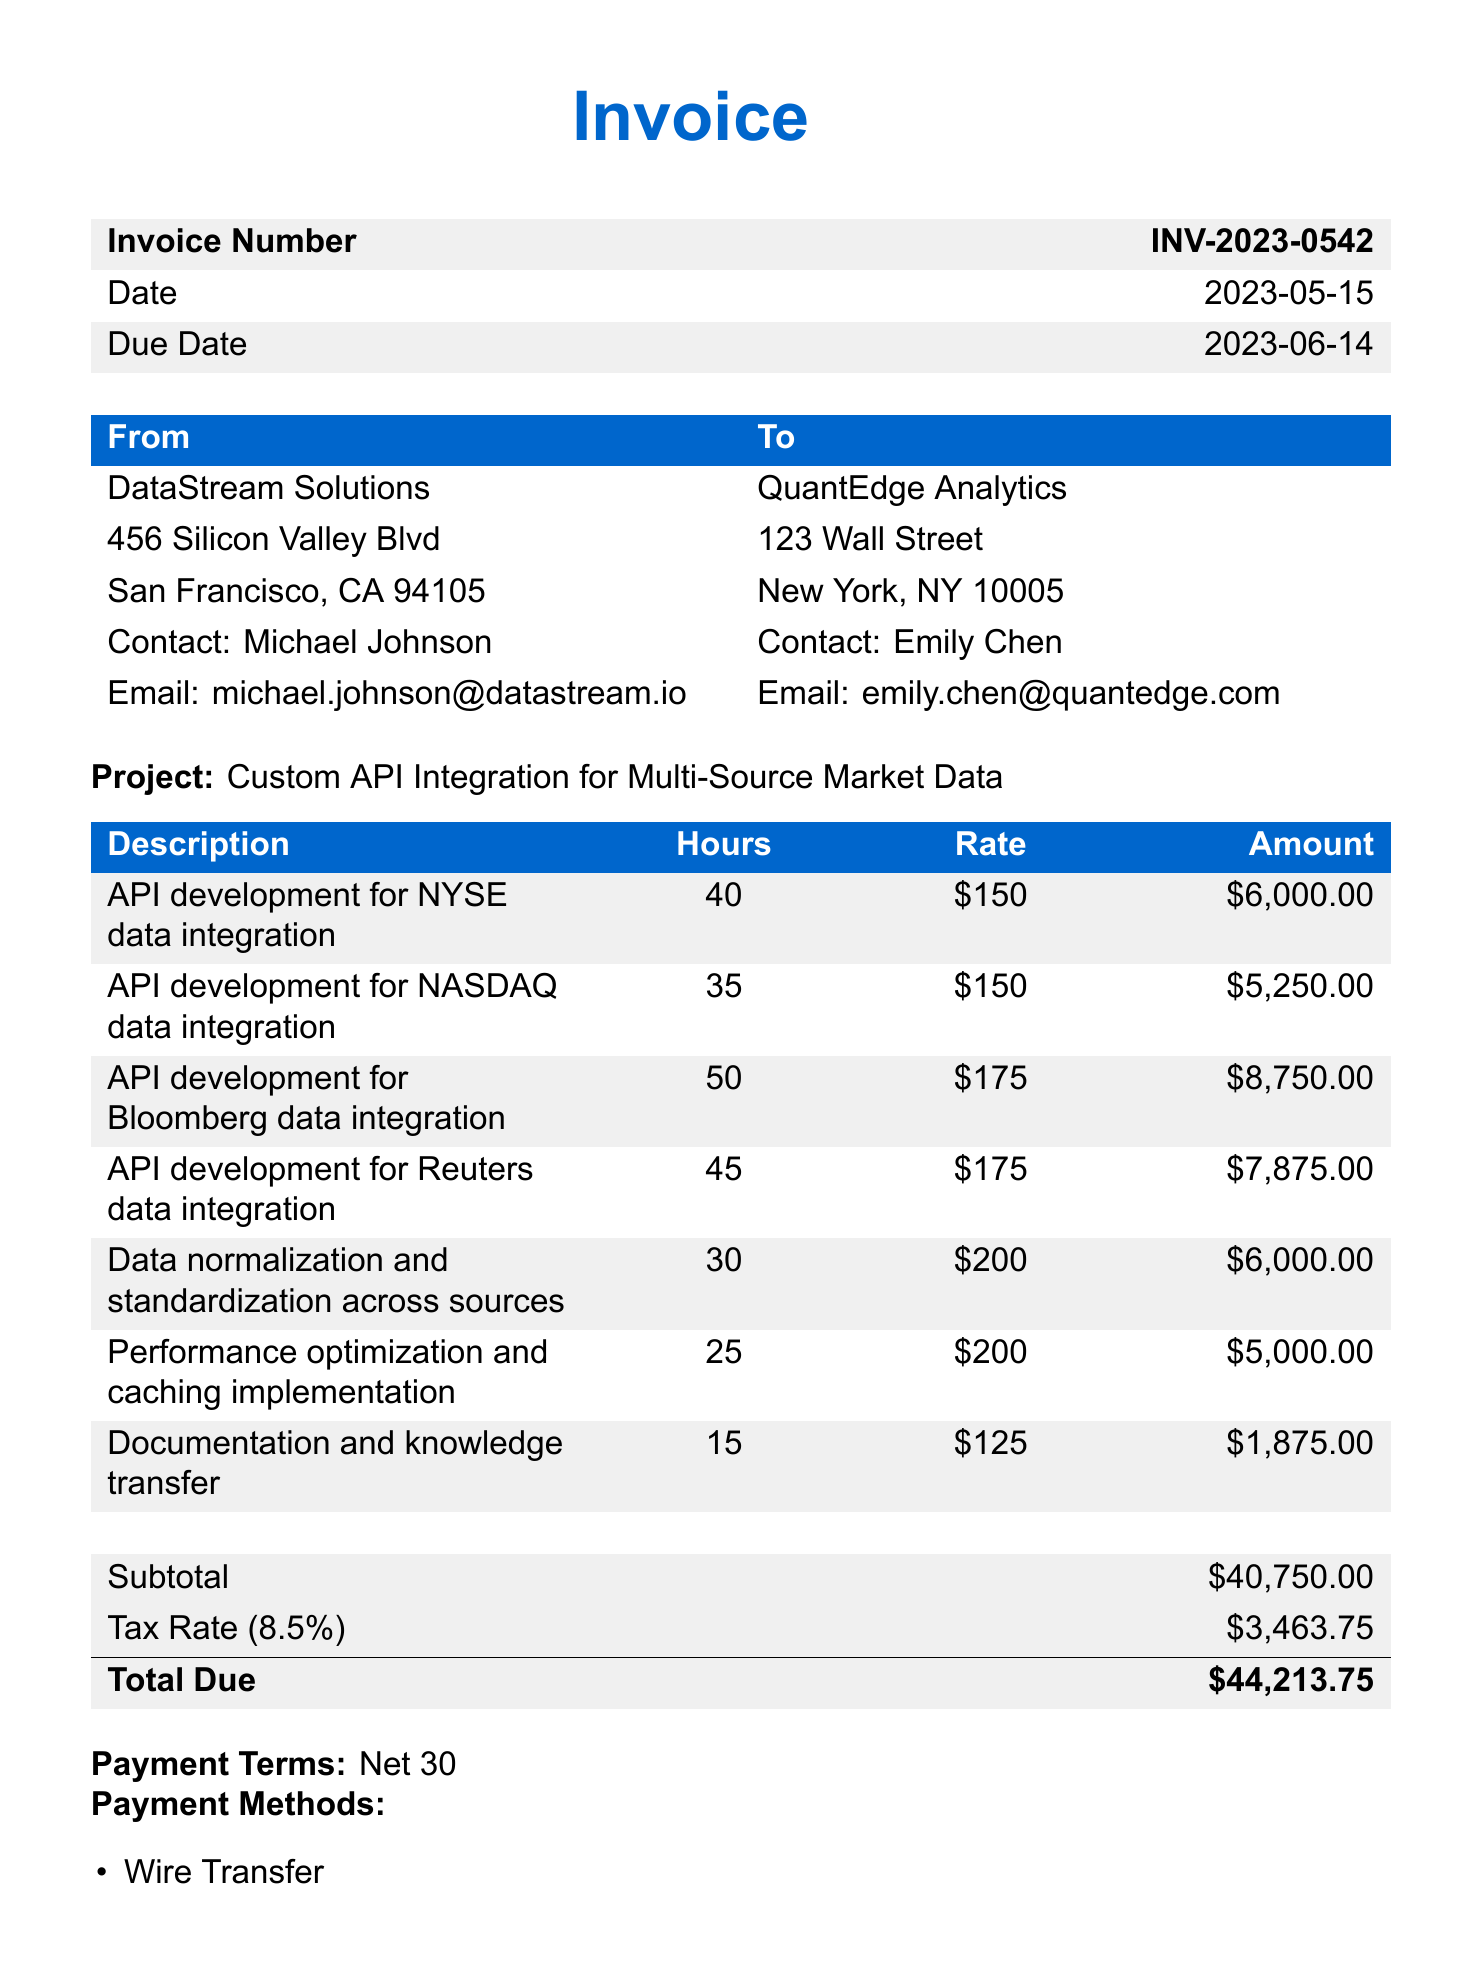What is the invoice number? The invoice number is specifically mentioned at the top of the document.
Answer: INV-2023-0542 Who is the contact person for the client? The contact person for QuantEdge Analytics is listed in the client section.
Answer: Emily Chen What is the total amount due? The total due is the final figure calculated at the end of the invoice section.
Answer: $44,213.75 What is the tax rate applied? The tax rate is detailed in the subsection that lists the subtotal and tax amount.
Answer: 8.5% How many hours were allocated for Bloomberg data integration? The hours for each line item are specifically listed under the description for Bloomberg data integration.
Answer: 50 What is the due date for this invoice? The due date is listed in the invoice details.
Answer: 2023-06-14 What method of payment incurs a processing fee? The payment methods section specifies which payment option includes a fee.
Answer: Credit Card (3% processing fee applies) What is the client's email address? The email address for the client is provided in the client contact details.
Answer: emily.chen@quantedge.com Which service provider created this invoice? The service provider's name is mentioned in the invoice header section.
Answer: DataStream Solutions 